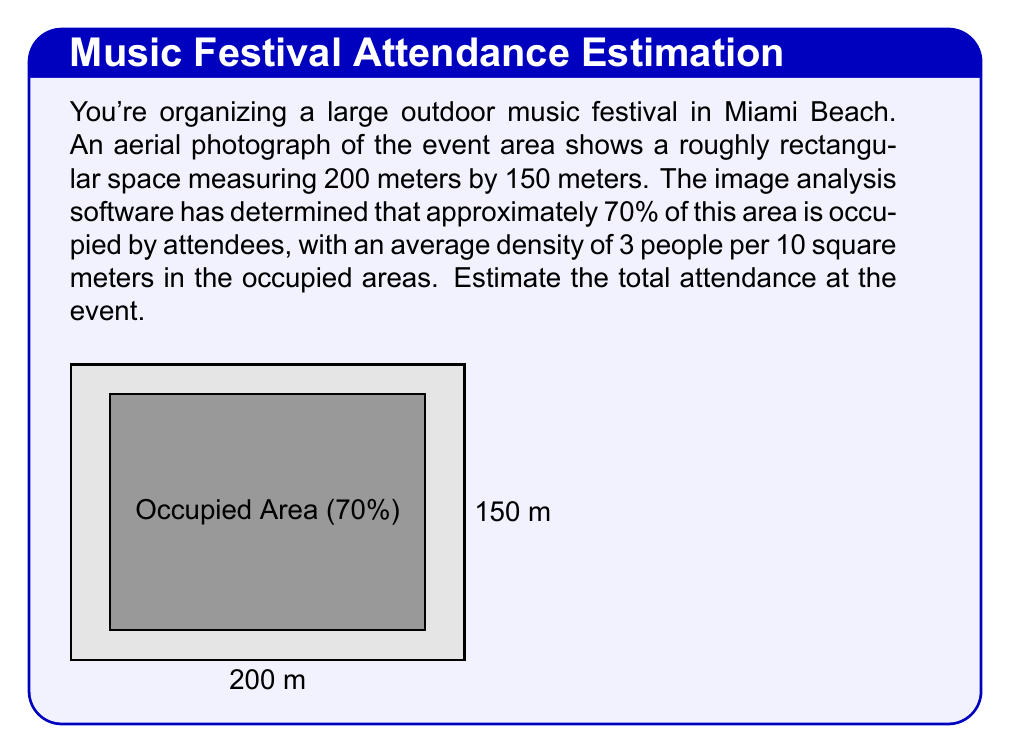Teach me how to tackle this problem. Let's approach this step-by-step:

1) First, calculate the total area of the event space:
   $$ \text{Total Area} = 200 \text{ m} \times 150 \text{ m} = 30,000 \text{ m}^2 $$

2) Calculate the occupied area (70% of total):
   $$ \text{Occupied Area} = 70\% \times 30,000 \text{ m}^2 = 0.7 \times 30,000 \text{ m}^2 = 21,000 \text{ m}^2 $$

3) Convert the density to people per square meter:
   $$ \text{Density} = \frac{3 \text{ people}}{10 \text{ m}^2} = 0.3 \text{ people/m}^2 $$

4) Calculate the estimated number of attendees:
   $$ \text{Attendees} = \text{Occupied Area} \times \text{Density} $$
   $$ \text{Attendees} = 21,000 \text{ m}^2 \times 0.3 \text{ people/m}^2 = 6,300 \text{ people} $$

Therefore, the estimated attendance at the event is 6,300 people.
Answer: 6,300 people 